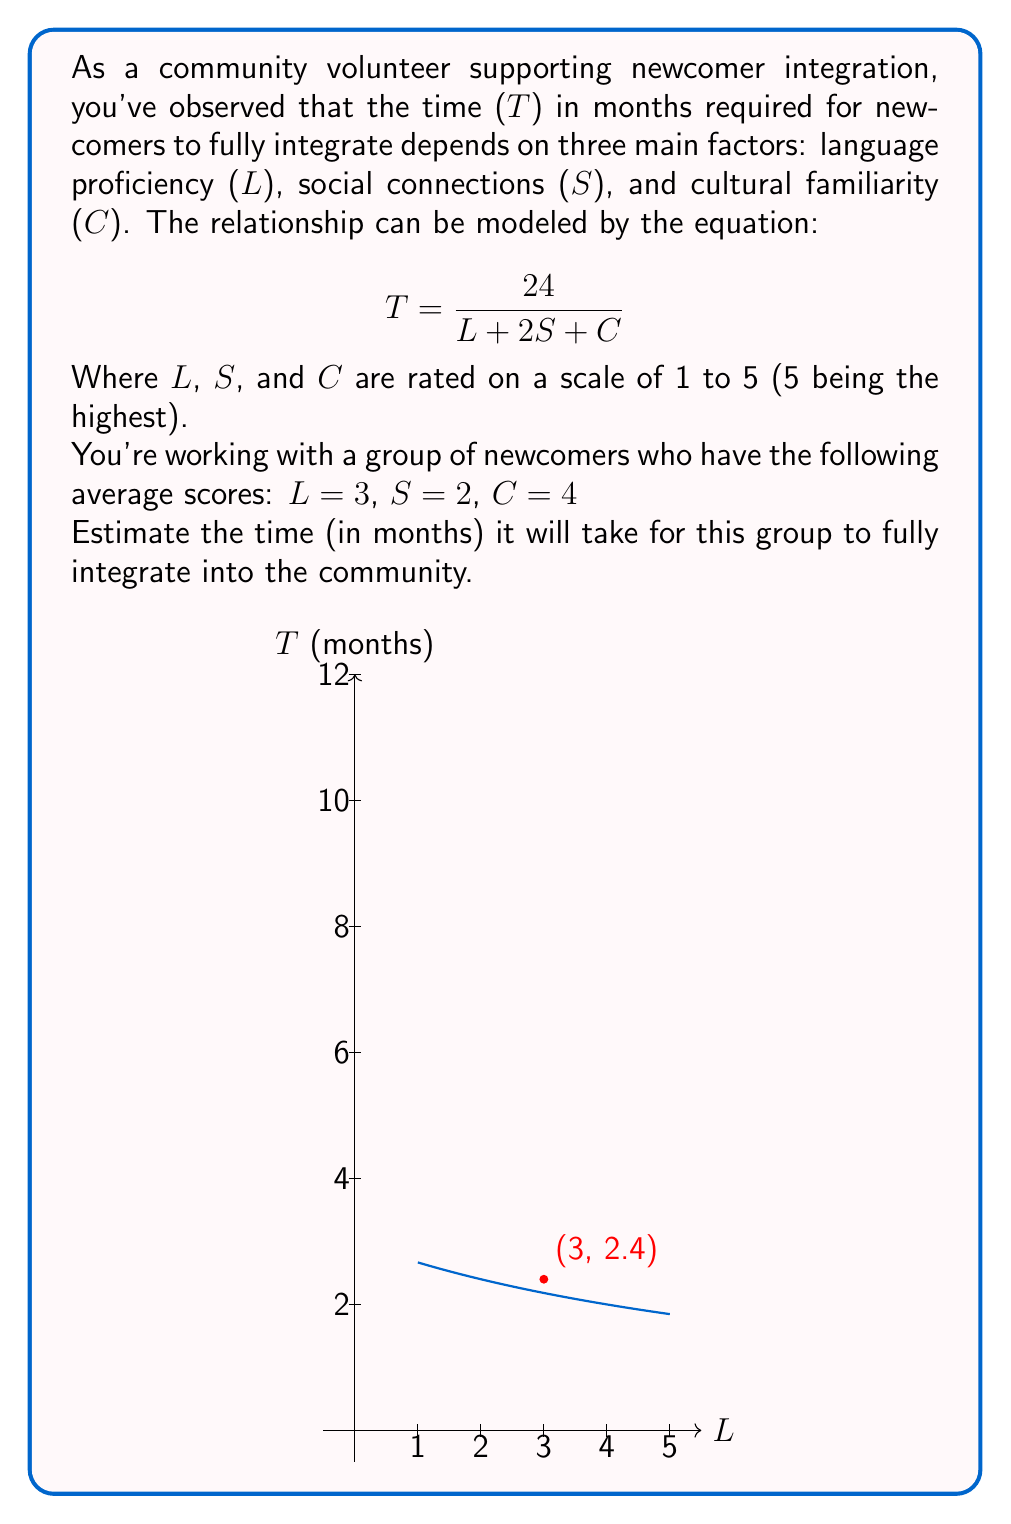Help me with this question. Let's approach this step-by-step:

1) We're given the equation: $$T = \frac{24}{L + 2S + C}$$

2) We're also given the values for each factor:
   L (Language proficiency) = 3
   S (Social connections) = 2
   C (Cultural familiarity) = 4

3) Let's substitute these values into our equation:

   $$T = \frac{24}{3 + 2(2) + 4}$$

4) Simplify the denominator:
   $$T = \frac{24}{3 + 4 + 4} = \frac{24}{11}$$

5) Calculate the final result:
   $$T = 2.1818...$$

6) Since T represents time in months, we should round to a reasonable precision. In this case, rounding to one decimal place is appropriate.

   $$T \approx 2.2 \text{ months}$$

The graph in the question visually represents this relationship, with the red dot indicating the solution point (3, 2.4) which corresponds to L = 3 and T ≈ 2.4 months.
Answer: 2.2 months 